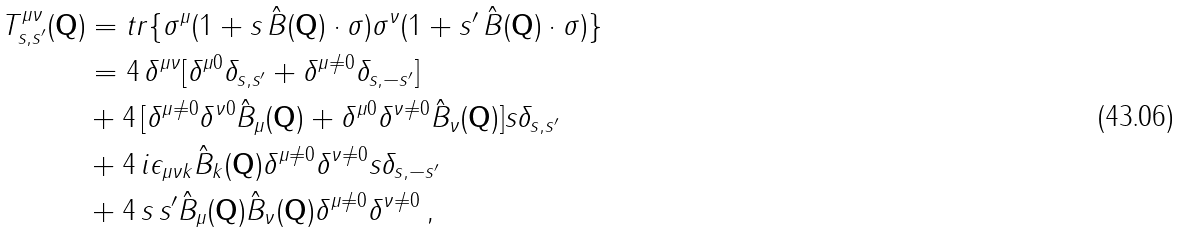<formula> <loc_0><loc_0><loc_500><loc_500>T _ { s , s ^ { \prime } } ^ { \mu \nu } ( \mathbf Q ) & = t r \{ \sigma ^ { \mu } ( 1 + s \, \hat { B } ( \mathbf Q ) \cdot \sigma ) \sigma ^ { \nu } ( 1 + s ^ { \prime } \, \hat { B } ( \mathbf Q ) \cdot \sigma ) \} \\ & = 4 \, \delta ^ { \mu \nu } [ \delta ^ { \mu 0 } \delta _ { s , s ^ { \prime } } + \delta ^ { \mu \neq 0 } \delta _ { s , - s ^ { \prime } } ] \\ & + 4 \, [ \delta ^ { \mu \neq 0 } \delta ^ { \nu 0 } \hat { B } _ { \mu } ( \mathbf Q ) + \delta ^ { \mu 0 } \delta ^ { \nu \neq 0 } \hat { B } _ { \nu } ( \mathbf Q ) ] s \delta _ { s , s ^ { \prime } } \\ & + 4 \, i \epsilon _ { \mu \nu k } \hat { B } _ { k } ( \mathbf Q ) \delta ^ { \mu \neq 0 } \delta ^ { \nu \neq 0 } s \delta _ { s , - s ^ { \prime } } \\ & + 4 \, s \, s ^ { \prime } \hat { B } _ { \mu } ( \mathbf Q ) \hat { B } _ { \nu } ( \mathbf Q ) \delta ^ { \mu \neq 0 } \delta ^ { \nu \neq 0 } \, ,</formula> 